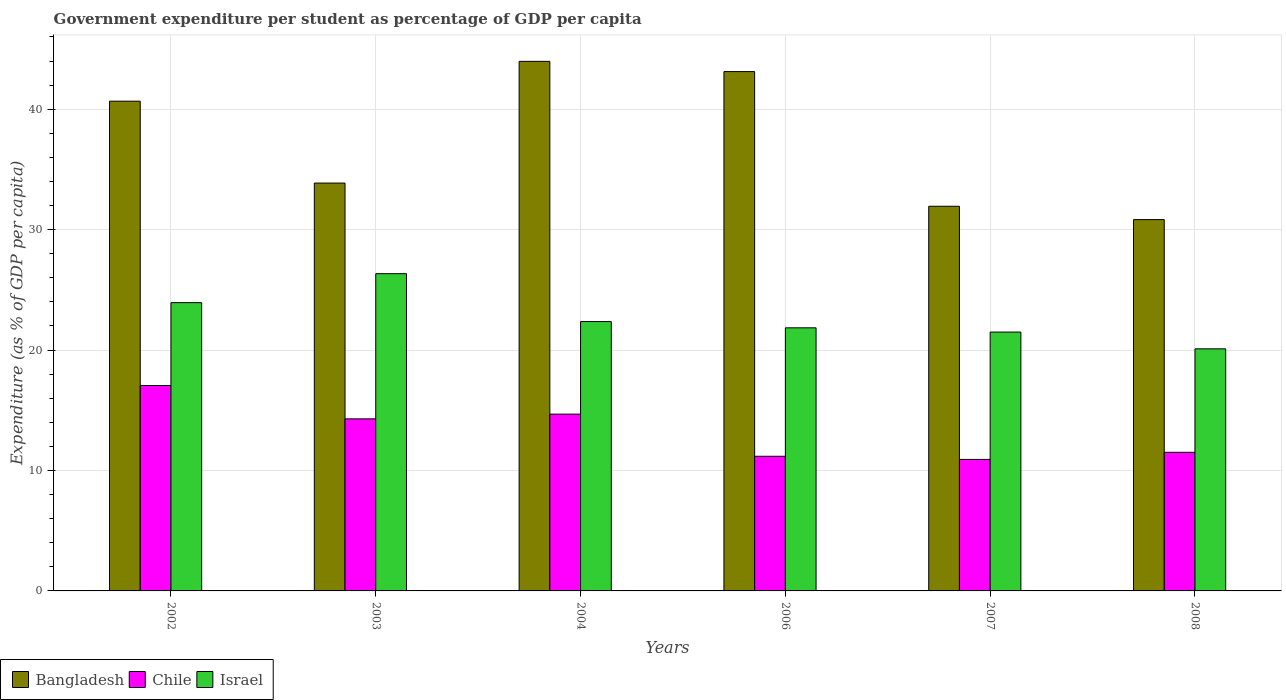How many different coloured bars are there?
Give a very brief answer. 3. How many groups of bars are there?
Make the answer very short. 6. Are the number of bars per tick equal to the number of legend labels?
Provide a short and direct response. Yes. Are the number of bars on each tick of the X-axis equal?
Your answer should be compact. Yes. How many bars are there on the 6th tick from the left?
Your response must be concise. 3. What is the percentage of expenditure per student in Israel in 2002?
Provide a succinct answer. 23.94. Across all years, what is the maximum percentage of expenditure per student in Bangladesh?
Offer a terse response. 43.97. Across all years, what is the minimum percentage of expenditure per student in Israel?
Ensure brevity in your answer.  20.1. In which year was the percentage of expenditure per student in Bangladesh maximum?
Offer a terse response. 2004. In which year was the percentage of expenditure per student in Chile minimum?
Provide a short and direct response. 2007. What is the total percentage of expenditure per student in Bangladesh in the graph?
Give a very brief answer. 224.41. What is the difference between the percentage of expenditure per student in Israel in 2002 and that in 2007?
Provide a short and direct response. 2.44. What is the difference between the percentage of expenditure per student in Israel in 2008 and the percentage of expenditure per student in Chile in 2002?
Your response must be concise. 3.04. What is the average percentage of expenditure per student in Chile per year?
Provide a short and direct response. 13.27. In the year 2007, what is the difference between the percentage of expenditure per student in Israel and percentage of expenditure per student in Bangladesh?
Your response must be concise. -10.45. What is the ratio of the percentage of expenditure per student in Israel in 2007 to that in 2008?
Give a very brief answer. 1.07. Is the percentage of expenditure per student in Chile in 2003 less than that in 2007?
Offer a very short reply. No. Is the difference between the percentage of expenditure per student in Israel in 2002 and 2004 greater than the difference between the percentage of expenditure per student in Bangladesh in 2002 and 2004?
Your answer should be compact. Yes. What is the difference between the highest and the second highest percentage of expenditure per student in Bangladesh?
Your answer should be compact. 0.85. What is the difference between the highest and the lowest percentage of expenditure per student in Israel?
Provide a succinct answer. 6.24. What does the 1st bar from the left in 2008 represents?
Offer a terse response. Bangladesh. Are all the bars in the graph horizontal?
Ensure brevity in your answer.  No. How many years are there in the graph?
Keep it short and to the point. 6. Does the graph contain any zero values?
Provide a short and direct response. No. Where does the legend appear in the graph?
Your answer should be very brief. Bottom left. How many legend labels are there?
Keep it short and to the point. 3. How are the legend labels stacked?
Provide a succinct answer. Horizontal. What is the title of the graph?
Your response must be concise. Government expenditure per student as percentage of GDP per capita. Does "Egypt, Arab Rep." appear as one of the legend labels in the graph?
Offer a terse response. No. What is the label or title of the Y-axis?
Give a very brief answer. Expenditure (as % of GDP per capita). What is the Expenditure (as % of GDP per capita) in Bangladesh in 2002?
Offer a very short reply. 40.67. What is the Expenditure (as % of GDP per capita) of Chile in 2002?
Offer a terse response. 17.06. What is the Expenditure (as % of GDP per capita) in Israel in 2002?
Provide a short and direct response. 23.94. What is the Expenditure (as % of GDP per capita) in Bangladesh in 2003?
Your answer should be very brief. 33.87. What is the Expenditure (as % of GDP per capita) in Chile in 2003?
Provide a short and direct response. 14.29. What is the Expenditure (as % of GDP per capita) in Israel in 2003?
Make the answer very short. 26.34. What is the Expenditure (as % of GDP per capita) of Bangladesh in 2004?
Offer a very short reply. 43.97. What is the Expenditure (as % of GDP per capita) of Chile in 2004?
Your answer should be compact. 14.68. What is the Expenditure (as % of GDP per capita) of Israel in 2004?
Ensure brevity in your answer.  22.37. What is the Expenditure (as % of GDP per capita) of Bangladesh in 2006?
Offer a very short reply. 43.12. What is the Expenditure (as % of GDP per capita) in Chile in 2006?
Your answer should be very brief. 11.18. What is the Expenditure (as % of GDP per capita) in Israel in 2006?
Give a very brief answer. 21.85. What is the Expenditure (as % of GDP per capita) in Bangladesh in 2007?
Offer a very short reply. 31.94. What is the Expenditure (as % of GDP per capita) in Chile in 2007?
Offer a very short reply. 10.92. What is the Expenditure (as % of GDP per capita) in Israel in 2007?
Provide a succinct answer. 21.49. What is the Expenditure (as % of GDP per capita) in Bangladesh in 2008?
Your answer should be compact. 30.83. What is the Expenditure (as % of GDP per capita) in Chile in 2008?
Offer a very short reply. 11.51. What is the Expenditure (as % of GDP per capita) in Israel in 2008?
Provide a succinct answer. 20.1. Across all years, what is the maximum Expenditure (as % of GDP per capita) of Bangladesh?
Provide a short and direct response. 43.97. Across all years, what is the maximum Expenditure (as % of GDP per capita) of Chile?
Give a very brief answer. 17.06. Across all years, what is the maximum Expenditure (as % of GDP per capita) in Israel?
Make the answer very short. 26.34. Across all years, what is the minimum Expenditure (as % of GDP per capita) in Bangladesh?
Your answer should be compact. 30.83. Across all years, what is the minimum Expenditure (as % of GDP per capita) in Chile?
Give a very brief answer. 10.92. Across all years, what is the minimum Expenditure (as % of GDP per capita) in Israel?
Offer a very short reply. 20.1. What is the total Expenditure (as % of GDP per capita) in Bangladesh in the graph?
Offer a terse response. 224.41. What is the total Expenditure (as % of GDP per capita) of Chile in the graph?
Give a very brief answer. 79.63. What is the total Expenditure (as % of GDP per capita) in Israel in the graph?
Your response must be concise. 136.09. What is the difference between the Expenditure (as % of GDP per capita) in Bangladesh in 2002 and that in 2003?
Give a very brief answer. 6.8. What is the difference between the Expenditure (as % of GDP per capita) in Chile in 2002 and that in 2003?
Make the answer very short. 2.77. What is the difference between the Expenditure (as % of GDP per capita) of Israel in 2002 and that in 2003?
Make the answer very short. -2.41. What is the difference between the Expenditure (as % of GDP per capita) of Bangladesh in 2002 and that in 2004?
Keep it short and to the point. -3.31. What is the difference between the Expenditure (as % of GDP per capita) in Chile in 2002 and that in 2004?
Provide a succinct answer. 2.38. What is the difference between the Expenditure (as % of GDP per capita) of Israel in 2002 and that in 2004?
Keep it short and to the point. 1.57. What is the difference between the Expenditure (as % of GDP per capita) in Bangladesh in 2002 and that in 2006?
Provide a short and direct response. -2.46. What is the difference between the Expenditure (as % of GDP per capita) of Chile in 2002 and that in 2006?
Offer a very short reply. 5.88. What is the difference between the Expenditure (as % of GDP per capita) of Israel in 2002 and that in 2006?
Provide a succinct answer. 2.09. What is the difference between the Expenditure (as % of GDP per capita) in Bangladesh in 2002 and that in 2007?
Provide a short and direct response. 8.73. What is the difference between the Expenditure (as % of GDP per capita) in Chile in 2002 and that in 2007?
Offer a very short reply. 6.14. What is the difference between the Expenditure (as % of GDP per capita) of Israel in 2002 and that in 2007?
Offer a very short reply. 2.44. What is the difference between the Expenditure (as % of GDP per capita) of Bangladesh in 2002 and that in 2008?
Give a very brief answer. 9.83. What is the difference between the Expenditure (as % of GDP per capita) of Chile in 2002 and that in 2008?
Your answer should be very brief. 5.55. What is the difference between the Expenditure (as % of GDP per capita) of Israel in 2002 and that in 2008?
Your answer should be compact. 3.84. What is the difference between the Expenditure (as % of GDP per capita) in Bangladesh in 2003 and that in 2004?
Give a very brief answer. -10.11. What is the difference between the Expenditure (as % of GDP per capita) of Chile in 2003 and that in 2004?
Offer a very short reply. -0.39. What is the difference between the Expenditure (as % of GDP per capita) in Israel in 2003 and that in 2004?
Offer a terse response. 3.98. What is the difference between the Expenditure (as % of GDP per capita) of Bangladesh in 2003 and that in 2006?
Your answer should be compact. -9.26. What is the difference between the Expenditure (as % of GDP per capita) of Chile in 2003 and that in 2006?
Make the answer very short. 3.11. What is the difference between the Expenditure (as % of GDP per capita) of Israel in 2003 and that in 2006?
Offer a very short reply. 4.5. What is the difference between the Expenditure (as % of GDP per capita) in Bangladesh in 2003 and that in 2007?
Offer a very short reply. 1.93. What is the difference between the Expenditure (as % of GDP per capita) in Chile in 2003 and that in 2007?
Offer a terse response. 3.37. What is the difference between the Expenditure (as % of GDP per capita) in Israel in 2003 and that in 2007?
Keep it short and to the point. 4.85. What is the difference between the Expenditure (as % of GDP per capita) in Bangladesh in 2003 and that in 2008?
Provide a short and direct response. 3.03. What is the difference between the Expenditure (as % of GDP per capita) in Chile in 2003 and that in 2008?
Keep it short and to the point. 2.78. What is the difference between the Expenditure (as % of GDP per capita) of Israel in 2003 and that in 2008?
Give a very brief answer. 6.24. What is the difference between the Expenditure (as % of GDP per capita) in Bangladesh in 2004 and that in 2006?
Give a very brief answer. 0.85. What is the difference between the Expenditure (as % of GDP per capita) of Chile in 2004 and that in 2006?
Give a very brief answer. 3.5. What is the difference between the Expenditure (as % of GDP per capita) of Israel in 2004 and that in 2006?
Your answer should be compact. 0.52. What is the difference between the Expenditure (as % of GDP per capita) in Bangladesh in 2004 and that in 2007?
Provide a short and direct response. 12.03. What is the difference between the Expenditure (as % of GDP per capita) in Chile in 2004 and that in 2007?
Offer a terse response. 3.76. What is the difference between the Expenditure (as % of GDP per capita) in Israel in 2004 and that in 2007?
Keep it short and to the point. 0.87. What is the difference between the Expenditure (as % of GDP per capita) in Bangladesh in 2004 and that in 2008?
Offer a very short reply. 13.14. What is the difference between the Expenditure (as % of GDP per capita) of Chile in 2004 and that in 2008?
Make the answer very short. 3.17. What is the difference between the Expenditure (as % of GDP per capita) of Israel in 2004 and that in 2008?
Make the answer very short. 2.27. What is the difference between the Expenditure (as % of GDP per capita) in Bangladesh in 2006 and that in 2007?
Make the answer very short. 11.18. What is the difference between the Expenditure (as % of GDP per capita) in Chile in 2006 and that in 2007?
Provide a short and direct response. 0.26. What is the difference between the Expenditure (as % of GDP per capita) of Israel in 2006 and that in 2007?
Your response must be concise. 0.35. What is the difference between the Expenditure (as % of GDP per capita) in Bangladesh in 2006 and that in 2008?
Provide a short and direct response. 12.29. What is the difference between the Expenditure (as % of GDP per capita) in Chile in 2006 and that in 2008?
Provide a short and direct response. -0.33. What is the difference between the Expenditure (as % of GDP per capita) of Israel in 2006 and that in 2008?
Your answer should be compact. 1.75. What is the difference between the Expenditure (as % of GDP per capita) in Bangladesh in 2007 and that in 2008?
Offer a terse response. 1.11. What is the difference between the Expenditure (as % of GDP per capita) in Chile in 2007 and that in 2008?
Give a very brief answer. -0.59. What is the difference between the Expenditure (as % of GDP per capita) of Israel in 2007 and that in 2008?
Make the answer very short. 1.39. What is the difference between the Expenditure (as % of GDP per capita) in Bangladesh in 2002 and the Expenditure (as % of GDP per capita) in Chile in 2003?
Your response must be concise. 26.38. What is the difference between the Expenditure (as % of GDP per capita) in Bangladesh in 2002 and the Expenditure (as % of GDP per capita) in Israel in 2003?
Give a very brief answer. 14.32. What is the difference between the Expenditure (as % of GDP per capita) in Chile in 2002 and the Expenditure (as % of GDP per capita) in Israel in 2003?
Keep it short and to the point. -9.29. What is the difference between the Expenditure (as % of GDP per capita) of Bangladesh in 2002 and the Expenditure (as % of GDP per capita) of Chile in 2004?
Offer a very short reply. 25.99. What is the difference between the Expenditure (as % of GDP per capita) of Bangladesh in 2002 and the Expenditure (as % of GDP per capita) of Israel in 2004?
Give a very brief answer. 18.3. What is the difference between the Expenditure (as % of GDP per capita) of Chile in 2002 and the Expenditure (as % of GDP per capita) of Israel in 2004?
Make the answer very short. -5.31. What is the difference between the Expenditure (as % of GDP per capita) in Bangladesh in 2002 and the Expenditure (as % of GDP per capita) in Chile in 2006?
Keep it short and to the point. 29.49. What is the difference between the Expenditure (as % of GDP per capita) of Bangladesh in 2002 and the Expenditure (as % of GDP per capita) of Israel in 2006?
Your answer should be compact. 18.82. What is the difference between the Expenditure (as % of GDP per capita) in Chile in 2002 and the Expenditure (as % of GDP per capita) in Israel in 2006?
Provide a succinct answer. -4.79. What is the difference between the Expenditure (as % of GDP per capita) of Bangladesh in 2002 and the Expenditure (as % of GDP per capita) of Chile in 2007?
Your response must be concise. 29.75. What is the difference between the Expenditure (as % of GDP per capita) of Bangladesh in 2002 and the Expenditure (as % of GDP per capita) of Israel in 2007?
Keep it short and to the point. 19.17. What is the difference between the Expenditure (as % of GDP per capita) in Chile in 2002 and the Expenditure (as % of GDP per capita) in Israel in 2007?
Offer a terse response. -4.44. What is the difference between the Expenditure (as % of GDP per capita) in Bangladesh in 2002 and the Expenditure (as % of GDP per capita) in Chile in 2008?
Provide a short and direct response. 29.16. What is the difference between the Expenditure (as % of GDP per capita) of Bangladesh in 2002 and the Expenditure (as % of GDP per capita) of Israel in 2008?
Offer a terse response. 20.57. What is the difference between the Expenditure (as % of GDP per capita) of Chile in 2002 and the Expenditure (as % of GDP per capita) of Israel in 2008?
Your response must be concise. -3.04. What is the difference between the Expenditure (as % of GDP per capita) of Bangladesh in 2003 and the Expenditure (as % of GDP per capita) of Chile in 2004?
Give a very brief answer. 19.19. What is the difference between the Expenditure (as % of GDP per capita) of Bangladesh in 2003 and the Expenditure (as % of GDP per capita) of Israel in 2004?
Keep it short and to the point. 11.5. What is the difference between the Expenditure (as % of GDP per capita) in Chile in 2003 and the Expenditure (as % of GDP per capita) in Israel in 2004?
Offer a very short reply. -8.08. What is the difference between the Expenditure (as % of GDP per capita) in Bangladesh in 2003 and the Expenditure (as % of GDP per capita) in Chile in 2006?
Your answer should be compact. 22.69. What is the difference between the Expenditure (as % of GDP per capita) in Bangladesh in 2003 and the Expenditure (as % of GDP per capita) in Israel in 2006?
Provide a succinct answer. 12.02. What is the difference between the Expenditure (as % of GDP per capita) in Chile in 2003 and the Expenditure (as % of GDP per capita) in Israel in 2006?
Provide a short and direct response. -7.56. What is the difference between the Expenditure (as % of GDP per capita) of Bangladesh in 2003 and the Expenditure (as % of GDP per capita) of Chile in 2007?
Your response must be concise. 22.95. What is the difference between the Expenditure (as % of GDP per capita) in Bangladesh in 2003 and the Expenditure (as % of GDP per capita) in Israel in 2007?
Provide a succinct answer. 12.37. What is the difference between the Expenditure (as % of GDP per capita) of Chile in 2003 and the Expenditure (as % of GDP per capita) of Israel in 2007?
Offer a very short reply. -7.21. What is the difference between the Expenditure (as % of GDP per capita) of Bangladesh in 2003 and the Expenditure (as % of GDP per capita) of Chile in 2008?
Offer a terse response. 22.36. What is the difference between the Expenditure (as % of GDP per capita) of Bangladesh in 2003 and the Expenditure (as % of GDP per capita) of Israel in 2008?
Your answer should be compact. 13.77. What is the difference between the Expenditure (as % of GDP per capita) of Chile in 2003 and the Expenditure (as % of GDP per capita) of Israel in 2008?
Your answer should be very brief. -5.81. What is the difference between the Expenditure (as % of GDP per capita) of Bangladesh in 2004 and the Expenditure (as % of GDP per capita) of Chile in 2006?
Offer a terse response. 32.79. What is the difference between the Expenditure (as % of GDP per capita) of Bangladesh in 2004 and the Expenditure (as % of GDP per capita) of Israel in 2006?
Ensure brevity in your answer.  22.13. What is the difference between the Expenditure (as % of GDP per capita) in Chile in 2004 and the Expenditure (as % of GDP per capita) in Israel in 2006?
Your answer should be very brief. -7.17. What is the difference between the Expenditure (as % of GDP per capita) of Bangladesh in 2004 and the Expenditure (as % of GDP per capita) of Chile in 2007?
Your response must be concise. 33.05. What is the difference between the Expenditure (as % of GDP per capita) of Bangladesh in 2004 and the Expenditure (as % of GDP per capita) of Israel in 2007?
Your answer should be very brief. 22.48. What is the difference between the Expenditure (as % of GDP per capita) in Chile in 2004 and the Expenditure (as % of GDP per capita) in Israel in 2007?
Your response must be concise. -6.81. What is the difference between the Expenditure (as % of GDP per capita) of Bangladesh in 2004 and the Expenditure (as % of GDP per capita) of Chile in 2008?
Provide a short and direct response. 32.46. What is the difference between the Expenditure (as % of GDP per capita) of Bangladesh in 2004 and the Expenditure (as % of GDP per capita) of Israel in 2008?
Your answer should be very brief. 23.87. What is the difference between the Expenditure (as % of GDP per capita) of Chile in 2004 and the Expenditure (as % of GDP per capita) of Israel in 2008?
Keep it short and to the point. -5.42. What is the difference between the Expenditure (as % of GDP per capita) in Bangladesh in 2006 and the Expenditure (as % of GDP per capita) in Chile in 2007?
Make the answer very short. 32.2. What is the difference between the Expenditure (as % of GDP per capita) of Bangladesh in 2006 and the Expenditure (as % of GDP per capita) of Israel in 2007?
Your response must be concise. 21.63. What is the difference between the Expenditure (as % of GDP per capita) in Chile in 2006 and the Expenditure (as % of GDP per capita) in Israel in 2007?
Give a very brief answer. -10.31. What is the difference between the Expenditure (as % of GDP per capita) in Bangladesh in 2006 and the Expenditure (as % of GDP per capita) in Chile in 2008?
Give a very brief answer. 31.61. What is the difference between the Expenditure (as % of GDP per capita) in Bangladesh in 2006 and the Expenditure (as % of GDP per capita) in Israel in 2008?
Offer a very short reply. 23.02. What is the difference between the Expenditure (as % of GDP per capita) in Chile in 2006 and the Expenditure (as % of GDP per capita) in Israel in 2008?
Your answer should be compact. -8.92. What is the difference between the Expenditure (as % of GDP per capita) in Bangladesh in 2007 and the Expenditure (as % of GDP per capita) in Chile in 2008?
Make the answer very short. 20.43. What is the difference between the Expenditure (as % of GDP per capita) in Bangladesh in 2007 and the Expenditure (as % of GDP per capita) in Israel in 2008?
Your answer should be compact. 11.84. What is the difference between the Expenditure (as % of GDP per capita) in Chile in 2007 and the Expenditure (as % of GDP per capita) in Israel in 2008?
Give a very brief answer. -9.18. What is the average Expenditure (as % of GDP per capita) in Bangladesh per year?
Keep it short and to the point. 37.4. What is the average Expenditure (as % of GDP per capita) in Chile per year?
Ensure brevity in your answer.  13.27. What is the average Expenditure (as % of GDP per capita) in Israel per year?
Offer a very short reply. 22.68. In the year 2002, what is the difference between the Expenditure (as % of GDP per capita) of Bangladesh and Expenditure (as % of GDP per capita) of Chile?
Your answer should be very brief. 23.61. In the year 2002, what is the difference between the Expenditure (as % of GDP per capita) of Bangladesh and Expenditure (as % of GDP per capita) of Israel?
Your answer should be very brief. 16.73. In the year 2002, what is the difference between the Expenditure (as % of GDP per capita) in Chile and Expenditure (as % of GDP per capita) in Israel?
Give a very brief answer. -6.88. In the year 2003, what is the difference between the Expenditure (as % of GDP per capita) of Bangladesh and Expenditure (as % of GDP per capita) of Chile?
Give a very brief answer. 19.58. In the year 2003, what is the difference between the Expenditure (as % of GDP per capita) of Bangladesh and Expenditure (as % of GDP per capita) of Israel?
Give a very brief answer. 7.52. In the year 2003, what is the difference between the Expenditure (as % of GDP per capita) of Chile and Expenditure (as % of GDP per capita) of Israel?
Your answer should be very brief. -12.06. In the year 2004, what is the difference between the Expenditure (as % of GDP per capita) of Bangladesh and Expenditure (as % of GDP per capita) of Chile?
Your response must be concise. 29.29. In the year 2004, what is the difference between the Expenditure (as % of GDP per capita) of Bangladesh and Expenditure (as % of GDP per capita) of Israel?
Provide a succinct answer. 21.61. In the year 2004, what is the difference between the Expenditure (as % of GDP per capita) of Chile and Expenditure (as % of GDP per capita) of Israel?
Ensure brevity in your answer.  -7.69. In the year 2006, what is the difference between the Expenditure (as % of GDP per capita) of Bangladesh and Expenditure (as % of GDP per capita) of Chile?
Your answer should be compact. 31.94. In the year 2006, what is the difference between the Expenditure (as % of GDP per capita) of Bangladesh and Expenditure (as % of GDP per capita) of Israel?
Ensure brevity in your answer.  21.28. In the year 2006, what is the difference between the Expenditure (as % of GDP per capita) of Chile and Expenditure (as % of GDP per capita) of Israel?
Ensure brevity in your answer.  -10.67. In the year 2007, what is the difference between the Expenditure (as % of GDP per capita) of Bangladesh and Expenditure (as % of GDP per capita) of Chile?
Provide a succinct answer. 21.02. In the year 2007, what is the difference between the Expenditure (as % of GDP per capita) of Bangladesh and Expenditure (as % of GDP per capita) of Israel?
Keep it short and to the point. 10.45. In the year 2007, what is the difference between the Expenditure (as % of GDP per capita) in Chile and Expenditure (as % of GDP per capita) in Israel?
Make the answer very short. -10.57. In the year 2008, what is the difference between the Expenditure (as % of GDP per capita) of Bangladesh and Expenditure (as % of GDP per capita) of Chile?
Provide a short and direct response. 19.32. In the year 2008, what is the difference between the Expenditure (as % of GDP per capita) of Bangladesh and Expenditure (as % of GDP per capita) of Israel?
Provide a short and direct response. 10.73. In the year 2008, what is the difference between the Expenditure (as % of GDP per capita) in Chile and Expenditure (as % of GDP per capita) in Israel?
Your answer should be compact. -8.59. What is the ratio of the Expenditure (as % of GDP per capita) in Bangladesh in 2002 to that in 2003?
Provide a short and direct response. 1.2. What is the ratio of the Expenditure (as % of GDP per capita) in Chile in 2002 to that in 2003?
Give a very brief answer. 1.19. What is the ratio of the Expenditure (as % of GDP per capita) in Israel in 2002 to that in 2003?
Ensure brevity in your answer.  0.91. What is the ratio of the Expenditure (as % of GDP per capita) in Bangladesh in 2002 to that in 2004?
Provide a short and direct response. 0.92. What is the ratio of the Expenditure (as % of GDP per capita) in Chile in 2002 to that in 2004?
Provide a short and direct response. 1.16. What is the ratio of the Expenditure (as % of GDP per capita) in Israel in 2002 to that in 2004?
Your answer should be compact. 1.07. What is the ratio of the Expenditure (as % of GDP per capita) in Bangladesh in 2002 to that in 2006?
Offer a terse response. 0.94. What is the ratio of the Expenditure (as % of GDP per capita) in Chile in 2002 to that in 2006?
Give a very brief answer. 1.53. What is the ratio of the Expenditure (as % of GDP per capita) of Israel in 2002 to that in 2006?
Provide a short and direct response. 1.1. What is the ratio of the Expenditure (as % of GDP per capita) in Bangladesh in 2002 to that in 2007?
Your response must be concise. 1.27. What is the ratio of the Expenditure (as % of GDP per capita) in Chile in 2002 to that in 2007?
Provide a short and direct response. 1.56. What is the ratio of the Expenditure (as % of GDP per capita) of Israel in 2002 to that in 2007?
Keep it short and to the point. 1.11. What is the ratio of the Expenditure (as % of GDP per capita) in Bangladesh in 2002 to that in 2008?
Keep it short and to the point. 1.32. What is the ratio of the Expenditure (as % of GDP per capita) of Chile in 2002 to that in 2008?
Provide a short and direct response. 1.48. What is the ratio of the Expenditure (as % of GDP per capita) in Israel in 2002 to that in 2008?
Ensure brevity in your answer.  1.19. What is the ratio of the Expenditure (as % of GDP per capita) of Bangladesh in 2003 to that in 2004?
Provide a succinct answer. 0.77. What is the ratio of the Expenditure (as % of GDP per capita) of Chile in 2003 to that in 2004?
Make the answer very short. 0.97. What is the ratio of the Expenditure (as % of GDP per capita) in Israel in 2003 to that in 2004?
Ensure brevity in your answer.  1.18. What is the ratio of the Expenditure (as % of GDP per capita) in Bangladesh in 2003 to that in 2006?
Your response must be concise. 0.79. What is the ratio of the Expenditure (as % of GDP per capita) of Chile in 2003 to that in 2006?
Give a very brief answer. 1.28. What is the ratio of the Expenditure (as % of GDP per capita) of Israel in 2003 to that in 2006?
Your answer should be compact. 1.21. What is the ratio of the Expenditure (as % of GDP per capita) of Bangladesh in 2003 to that in 2007?
Provide a short and direct response. 1.06. What is the ratio of the Expenditure (as % of GDP per capita) of Chile in 2003 to that in 2007?
Provide a succinct answer. 1.31. What is the ratio of the Expenditure (as % of GDP per capita) in Israel in 2003 to that in 2007?
Keep it short and to the point. 1.23. What is the ratio of the Expenditure (as % of GDP per capita) of Bangladesh in 2003 to that in 2008?
Make the answer very short. 1.1. What is the ratio of the Expenditure (as % of GDP per capita) in Chile in 2003 to that in 2008?
Your response must be concise. 1.24. What is the ratio of the Expenditure (as % of GDP per capita) in Israel in 2003 to that in 2008?
Keep it short and to the point. 1.31. What is the ratio of the Expenditure (as % of GDP per capita) in Bangladesh in 2004 to that in 2006?
Your response must be concise. 1.02. What is the ratio of the Expenditure (as % of GDP per capita) in Chile in 2004 to that in 2006?
Ensure brevity in your answer.  1.31. What is the ratio of the Expenditure (as % of GDP per capita) of Israel in 2004 to that in 2006?
Offer a terse response. 1.02. What is the ratio of the Expenditure (as % of GDP per capita) in Bangladesh in 2004 to that in 2007?
Provide a succinct answer. 1.38. What is the ratio of the Expenditure (as % of GDP per capita) of Chile in 2004 to that in 2007?
Offer a terse response. 1.34. What is the ratio of the Expenditure (as % of GDP per capita) in Israel in 2004 to that in 2007?
Your answer should be very brief. 1.04. What is the ratio of the Expenditure (as % of GDP per capita) of Bangladesh in 2004 to that in 2008?
Provide a short and direct response. 1.43. What is the ratio of the Expenditure (as % of GDP per capita) in Chile in 2004 to that in 2008?
Keep it short and to the point. 1.28. What is the ratio of the Expenditure (as % of GDP per capita) in Israel in 2004 to that in 2008?
Give a very brief answer. 1.11. What is the ratio of the Expenditure (as % of GDP per capita) in Bangladesh in 2006 to that in 2007?
Keep it short and to the point. 1.35. What is the ratio of the Expenditure (as % of GDP per capita) in Chile in 2006 to that in 2007?
Provide a succinct answer. 1.02. What is the ratio of the Expenditure (as % of GDP per capita) in Israel in 2006 to that in 2007?
Your response must be concise. 1.02. What is the ratio of the Expenditure (as % of GDP per capita) of Bangladesh in 2006 to that in 2008?
Keep it short and to the point. 1.4. What is the ratio of the Expenditure (as % of GDP per capita) of Chile in 2006 to that in 2008?
Your answer should be compact. 0.97. What is the ratio of the Expenditure (as % of GDP per capita) of Israel in 2006 to that in 2008?
Your answer should be compact. 1.09. What is the ratio of the Expenditure (as % of GDP per capita) in Bangladesh in 2007 to that in 2008?
Your answer should be very brief. 1.04. What is the ratio of the Expenditure (as % of GDP per capita) in Chile in 2007 to that in 2008?
Provide a short and direct response. 0.95. What is the ratio of the Expenditure (as % of GDP per capita) of Israel in 2007 to that in 2008?
Offer a very short reply. 1.07. What is the difference between the highest and the second highest Expenditure (as % of GDP per capita) of Bangladesh?
Provide a succinct answer. 0.85. What is the difference between the highest and the second highest Expenditure (as % of GDP per capita) of Chile?
Give a very brief answer. 2.38. What is the difference between the highest and the second highest Expenditure (as % of GDP per capita) of Israel?
Give a very brief answer. 2.41. What is the difference between the highest and the lowest Expenditure (as % of GDP per capita) in Bangladesh?
Ensure brevity in your answer.  13.14. What is the difference between the highest and the lowest Expenditure (as % of GDP per capita) of Chile?
Your response must be concise. 6.14. What is the difference between the highest and the lowest Expenditure (as % of GDP per capita) in Israel?
Keep it short and to the point. 6.24. 